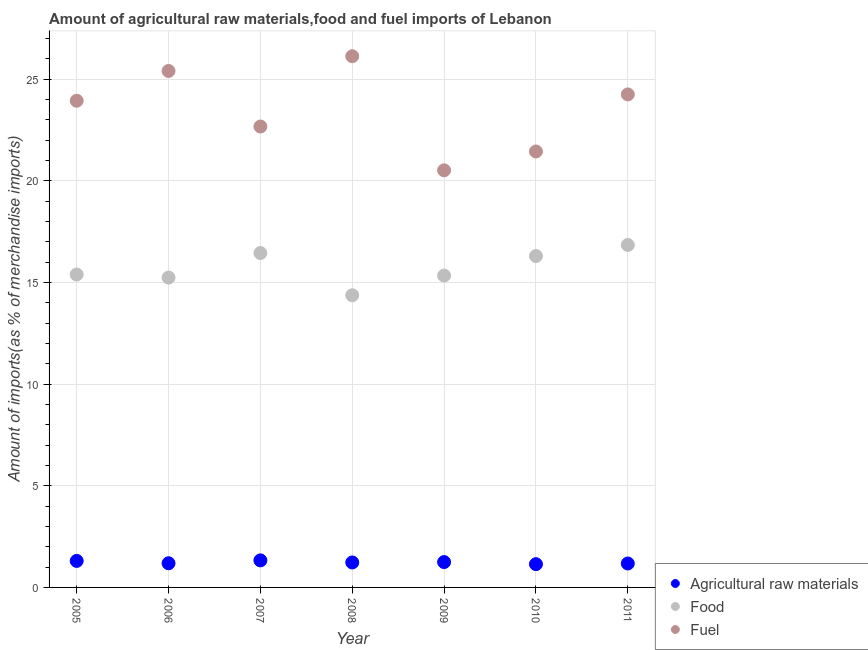What is the percentage of fuel imports in 2008?
Your answer should be compact. 26.12. Across all years, what is the maximum percentage of fuel imports?
Give a very brief answer. 26.12. Across all years, what is the minimum percentage of fuel imports?
Offer a very short reply. 20.51. In which year was the percentage of fuel imports maximum?
Provide a short and direct response. 2008. In which year was the percentage of fuel imports minimum?
Your answer should be very brief. 2009. What is the total percentage of raw materials imports in the graph?
Provide a succinct answer. 8.62. What is the difference between the percentage of food imports in 2009 and that in 2011?
Make the answer very short. -1.5. What is the difference between the percentage of food imports in 2010 and the percentage of fuel imports in 2005?
Offer a very short reply. -7.64. What is the average percentage of food imports per year?
Make the answer very short. 15.7. In the year 2006, what is the difference between the percentage of raw materials imports and percentage of food imports?
Your answer should be compact. -14.05. What is the ratio of the percentage of fuel imports in 2006 to that in 2010?
Provide a succinct answer. 1.18. Is the difference between the percentage of fuel imports in 2008 and 2009 greater than the difference between the percentage of food imports in 2008 and 2009?
Offer a terse response. Yes. What is the difference between the highest and the second highest percentage of fuel imports?
Give a very brief answer. 0.73. What is the difference between the highest and the lowest percentage of fuel imports?
Keep it short and to the point. 5.61. In how many years, is the percentage of raw materials imports greater than the average percentage of raw materials imports taken over all years?
Offer a terse response. 3. Is the sum of the percentage of food imports in 2009 and 2010 greater than the maximum percentage of raw materials imports across all years?
Your response must be concise. Yes. Is the percentage of fuel imports strictly greater than the percentage of food imports over the years?
Your answer should be very brief. Yes. Is the percentage of raw materials imports strictly less than the percentage of fuel imports over the years?
Your answer should be very brief. Yes. How many dotlines are there?
Make the answer very short. 3. How many years are there in the graph?
Offer a very short reply. 7. What is the difference between two consecutive major ticks on the Y-axis?
Offer a terse response. 5. Where does the legend appear in the graph?
Give a very brief answer. Bottom right. What is the title of the graph?
Your answer should be very brief. Amount of agricultural raw materials,food and fuel imports of Lebanon. What is the label or title of the X-axis?
Ensure brevity in your answer.  Year. What is the label or title of the Y-axis?
Your answer should be very brief. Amount of imports(as % of merchandise imports). What is the Amount of imports(as % of merchandise imports) of Agricultural raw materials in 2005?
Keep it short and to the point. 1.3. What is the Amount of imports(as % of merchandise imports) of Food in 2005?
Your answer should be very brief. 15.39. What is the Amount of imports(as % of merchandise imports) of Fuel in 2005?
Your answer should be compact. 23.93. What is the Amount of imports(as % of merchandise imports) of Agricultural raw materials in 2006?
Give a very brief answer. 1.19. What is the Amount of imports(as % of merchandise imports) in Food in 2006?
Ensure brevity in your answer.  15.24. What is the Amount of imports(as % of merchandise imports) of Fuel in 2006?
Offer a very short reply. 25.4. What is the Amount of imports(as % of merchandise imports) of Agricultural raw materials in 2007?
Your answer should be very brief. 1.33. What is the Amount of imports(as % of merchandise imports) in Food in 2007?
Provide a succinct answer. 16.44. What is the Amount of imports(as % of merchandise imports) of Fuel in 2007?
Your answer should be very brief. 22.67. What is the Amount of imports(as % of merchandise imports) of Agricultural raw materials in 2008?
Offer a very short reply. 1.23. What is the Amount of imports(as % of merchandise imports) of Food in 2008?
Your answer should be compact. 14.37. What is the Amount of imports(as % of merchandise imports) in Fuel in 2008?
Provide a succinct answer. 26.12. What is the Amount of imports(as % of merchandise imports) of Agricultural raw materials in 2009?
Keep it short and to the point. 1.25. What is the Amount of imports(as % of merchandise imports) in Food in 2009?
Your answer should be very brief. 15.34. What is the Amount of imports(as % of merchandise imports) of Fuel in 2009?
Your response must be concise. 20.51. What is the Amount of imports(as % of merchandise imports) of Agricultural raw materials in 2010?
Provide a succinct answer. 1.14. What is the Amount of imports(as % of merchandise imports) in Food in 2010?
Make the answer very short. 16.3. What is the Amount of imports(as % of merchandise imports) of Fuel in 2010?
Keep it short and to the point. 21.44. What is the Amount of imports(as % of merchandise imports) in Agricultural raw materials in 2011?
Offer a very short reply. 1.18. What is the Amount of imports(as % of merchandise imports) in Food in 2011?
Provide a short and direct response. 16.84. What is the Amount of imports(as % of merchandise imports) of Fuel in 2011?
Your response must be concise. 24.25. Across all years, what is the maximum Amount of imports(as % of merchandise imports) in Agricultural raw materials?
Provide a succinct answer. 1.33. Across all years, what is the maximum Amount of imports(as % of merchandise imports) of Food?
Give a very brief answer. 16.84. Across all years, what is the maximum Amount of imports(as % of merchandise imports) of Fuel?
Offer a very short reply. 26.12. Across all years, what is the minimum Amount of imports(as % of merchandise imports) in Agricultural raw materials?
Provide a succinct answer. 1.14. Across all years, what is the minimum Amount of imports(as % of merchandise imports) of Food?
Provide a succinct answer. 14.37. Across all years, what is the minimum Amount of imports(as % of merchandise imports) in Fuel?
Offer a very short reply. 20.51. What is the total Amount of imports(as % of merchandise imports) in Agricultural raw materials in the graph?
Your answer should be very brief. 8.62. What is the total Amount of imports(as % of merchandise imports) in Food in the graph?
Provide a short and direct response. 109.91. What is the total Amount of imports(as % of merchandise imports) of Fuel in the graph?
Make the answer very short. 164.32. What is the difference between the Amount of imports(as % of merchandise imports) of Agricultural raw materials in 2005 and that in 2006?
Ensure brevity in your answer.  0.11. What is the difference between the Amount of imports(as % of merchandise imports) in Food in 2005 and that in 2006?
Offer a very short reply. 0.15. What is the difference between the Amount of imports(as % of merchandise imports) of Fuel in 2005 and that in 2006?
Ensure brevity in your answer.  -1.46. What is the difference between the Amount of imports(as % of merchandise imports) of Agricultural raw materials in 2005 and that in 2007?
Your response must be concise. -0.03. What is the difference between the Amount of imports(as % of merchandise imports) in Food in 2005 and that in 2007?
Provide a succinct answer. -1.06. What is the difference between the Amount of imports(as % of merchandise imports) of Fuel in 2005 and that in 2007?
Keep it short and to the point. 1.27. What is the difference between the Amount of imports(as % of merchandise imports) in Agricultural raw materials in 2005 and that in 2008?
Offer a terse response. 0.08. What is the difference between the Amount of imports(as % of merchandise imports) in Food in 2005 and that in 2008?
Make the answer very short. 1.02. What is the difference between the Amount of imports(as % of merchandise imports) in Fuel in 2005 and that in 2008?
Give a very brief answer. -2.19. What is the difference between the Amount of imports(as % of merchandise imports) in Agricultural raw materials in 2005 and that in 2009?
Your answer should be compact. 0.06. What is the difference between the Amount of imports(as % of merchandise imports) in Food in 2005 and that in 2009?
Your answer should be very brief. 0.05. What is the difference between the Amount of imports(as % of merchandise imports) in Fuel in 2005 and that in 2009?
Your response must be concise. 3.42. What is the difference between the Amount of imports(as % of merchandise imports) of Agricultural raw materials in 2005 and that in 2010?
Your response must be concise. 0.16. What is the difference between the Amount of imports(as % of merchandise imports) in Food in 2005 and that in 2010?
Make the answer very short. -0.91. What is the difference between the Amount of imports(as % of merchandise imports) in Fuel in 2005 and that in 2010?
Your answer should be very brief. 2.49. What is the difference between the Amount of imports(as % of merchandise imports) in Agricultural raw materials in 2005 and that in 2011?
Give a very brief answer. 0.13. What is the difference between the Amount of imports(as % of merchandise imports) of Food in 2005 and that in 2011?
Your answer should be very brief. -1.45. What is the difference between the Amount of imports(as % of merchandise imports) in Fuel in 2005 and that in 2011?
Offer a terse response. -0.31. What is the difference between the Amount of imports(as % of merchandise imports) in Agricultural raw materials in 2006 and that in 2007?
Offer a very short reply. -0.14. What is the difference between the Amount of imports(as % of merchandise imports) of Food in 2006 and that in 2007?
Give a very brief answer. -1.21. What is the difference between the Amount of imports(as % of merchandise imports) of Fuel in 2006 and that in 2007?
Ensure brevity in your answer.  2.73. What is the difference between the Amount of imports(as % of merchandise imports) in Agricultural raw materials in 2006 and that in 2008?
Your answer should be very brief. -0.04. What is the difference between the Amount of imports(as % of merchandise imports) in Food in 2006 and that in 2008?
Provide a succinct answer. 0.87. What is the difference between the Amount of imports(as % of merchandise imports) in Fuel in 2006 and that in 2008?
Ensure brevity in your answer.  -0.73. What is the difference between the Amount of imports(as % of merchandise imports) of Agricultural raw materials in 2006 and that in 2009?
Provide a succinct answer. -0.06. What is the difference between the Amount of imports(as % of merchandise imports) of Food in 2006 and that in 2009?
Your answer should be very brief. -0.1. What is the difference between the Amount of imports(as % of merchandise imports) of Fuel in 2006 and that in 2009?
Provide a succinct answer. 4.89. What is the difference between the Amount of imports(as % of merchandise imports) of Agricultural raw materials in 2006 and that in 2010?
Provide a short and direct response. 0.04. What is the difference between the Amount of imports(as % of merchandise imports) of Food in 2006 and that in 2010?
Give a very brief answer. -1.06. What is the difference between the Amount of imports(as % of merchandise imports) of Fuel in 2006 and that in 2010?
Your response must be concise. 3.96. What is the difference between the Amount of imports(as % of merchandise imports) in Agricultural raw materials in 2006 and that in 2011?
Give a very brief answer. 0.01. What is the difference between the Amount of imports(as % of merchandise imports) in Food in 2006 and that in 2011?
Give a very brief answer. -1.6. What is the difference between the Amount of imports(as % of merchandise imports) of Fuel in 2006 and that in 2011?
Offer a terse response. 1.15. What is the difference between the Amount of imports(as % of merchandise imports) of Agricultural raw materials in 2007 and that in 2008?
Make the answer very short. 0.1. What is the difference between the Amount of imports(as % of merchandise imports) in Food in 2007 and that in 2008?
Give a very brief answer. 2.08. What is the difference between the Amount of imports(as % of merchandise imports) in Fuel in 2007 and that in 2008?
Your answer should be compact. -3.46. What is the difference between the Amount of imports(as % of merchandise imports) in Agricultural raw materials in 2007 and that in 2009?
Your answer should be compact. 0.08. What is the difference between the Amount of imports(as % of merchandise imports) in Food in 2007 and that in 2009?
Provide a succinct answer. 1.11. What is the difference between the Amount of imports(as % of merchandise imports) of Fuel in 2007 and that in 2009?
Keep it short and to the point. 2.15. What is the difference between the Amount of imports(as % of merchandise imports) of Agricultural raw materials in 2007 and that in 2010?
Your response must be concise. 0.19. What is the difference between the Amount of imports(as % of merchandise imports) of Food in 2007 and that in 2010?
Provide a succinct answer. 0.15. What is the difference between the Amount of imports(as % of merchandise imports) in Fuel in 2007 and that in 2010?
Your response must be concise. 1.23. What is the difference between the Amount of imports(as % of merchandise imports) in Agricultural raw materials in 2007 and that in 2011?
Make the answer very short. 0.15. What is the difference between the Amount of imports(as % of merchandise imports) in Food in 2007 and that in 2011?
Make the answer very short. -0.4. What is the difference between the Amount of imports(as % of merchandise imports) of Fuel in 2007 and that in 2011?
Give a very brief answer. -1.58. What is the difference between the Amount of imports(as % of merchandise imports) in Agricultural raw materials in 2008 and that in 2009?
Your answer should be compact. -0.02. What is the difference between the Amount of imports(as % of merchandise imports) in Food in 2008 and that in 2009?
Your answer should be compact. -0.97. What is the difference between the Amount of imports(as % of merchandise imports) in Fuel in 2008 and that in 2009?
Offer a terse response. 5.61. What is the difference between the Amount of imports(as % of merchandise imports) of Agricultural raw materials in 2008 and that in 2010?
Keep it short and to the point. 0.08. What is the difference between the Amount of imports(as % of merchandise imports) in Food in 2008 and that in 2010?
Give a very brief answer. -1.93. What is the difference between the Amount of imports(as % of merchandise imports) in Fuel in 2008 and that in 2010?
Provide a short and direct response. 4.68. What is the difference between the Amount of imports(as % of merchandise imports) in Agricultural raw materials in 2008 and that in 2011?
Keep it short and to the point. 0.05. What is the difference between the Amount of imports(as % of merchandise imports) in Food in 2008 and that in 2011?
Keep it short and to the point. -2.47. What is the difference between the Amount of imports(as % of merchandise imports) in Fuel in 2008 and that in 2011?
Give a very brief answer. 1.88. What is the difference between the Amount of imports(as % of merchandise imports) of Agricultural raw materials in 2009 and that in 2010?
Offer a terse response. 0.1. What is the difference between the Amount of imports(as % of merchandise imports) of Food in 2009 and that in 2010?
Give a very brief answer. -0.96. What is the difference between the Amount of imports(as % of merchandise imports) in Fuel in 2009 and that in 2010?
Your answer should be compact. -0.93. What is the difference between the Amount of imports(as % of merchandise imports) of Agricultural raw materials in 2009 and that in 2011?
Your response must be concise. 0.07. What is the difference between the Amount of imports(as % of merchandise imports) of Food in 2009 and that in 2011?
Give a very brief answer. -1.5. What is the difference between the Amount of imports(as % of merchandise imports) in Fuel in 2009 and that in 2011?
Your answer should be compact. -3.73. What is the difference between the Amount of imports(as % of merchandise imports) in Agricultural raw materials in 2010 and that in 2011?
Provide a short and direct response. -0.03. What is the difference between the Amount of imports(as % of merchandise imports) of Food in 2010 and that in 2011?
Offer a terse response. -0.54. What is the difference between the Amount of imports(as % of merchandise imports) in Fuel in 2010 and that in 2011?
Your response must be concise. -2.81. What is the difference between the Amount of imports(as % of merchandise imports) of Agricultural raw materials in 2005 and the Amount of imports(as % of merchandise imports) of Food in 2006?
Provide a succinct answer. -13.93. What is the difference between the Amount of imports(as % of merchandise imports) of Agricultural raw materials in 2005 and the Amount of imports(as % of merchandise imports) of Fuel in 2006?
Keep it short and to the point. -24.09. What is the difference between the Amount of imports(as % of merchandise imports) in Food in 2005 and the Amount of imports(as % of merchandise imports) in Fuel in 2006?
Your response must be concise. -10.01. What is the difference between the Amount of imports(as % of merchandise imports) in Agricultural raw materials in 2005 and the Amount of imports(as % of merchandise imports) in Food in 2007?
Make the answer very short. -15.14. What is the difference between the Amount of imports(as % of merchandise imports) of Agricultural raw materials in 2005 and the Amount of imports(as % of merchandise imports) of Fuel in 2007?
Your answer should be very brief. -21.36. What is the difference between the Amount of imports(as % of merchandise imports) in Food in 2005 and the Amount of imports(as % of merchandise imports) in Fuel in 2007?
Ensure brevity in your answer.  -7.28. What is the difference between the Amount of imports(as % of merchandise imports) of Agricultural raw materials in 2005 and the Amount of imports(as % of merchandise imports) of Food in 2008?
Offer a terse response. -13.06. What is the difference between the Amount of imports(as % of merchandise imports) of Agricultural raw materials in 2005 and the Amount of imports(as % of merchandise imports) of Fuel in 2008?
Your response must be concise. -24.82. What is the difference between the Amount of imports(as % of merchandise imports) in Food in 2005 and the Amount of imports(as % of merchandise imports) in Fuel in 2008?
Provide a short and direct response. -10.74. What is the difference between the Amount of imports(as % of merchandise imports) in Agricultural raw materials in 2005 and the Amount of imports(as % of merchandise imports) in Food in 2009?
Provide a short and direct response. -14.03. What is the difference between the Amount of imports(as % of merchandise imports) of Agricultural raw materials in 2005 and the Amount of imports(as % of merchandise imports) of Fuel in 2009?
Your answer should be compact. -19.21. What is the difference between the Amount of imports(as % of merchandise imports) in Food in 2005 and the Amount of imports(as % of merchandise imports) in Fuel in 2009?
Make the answer very short. -5.12. What is the difference between the Amount of imports(as % of merchandise imports) in Agricultural raw materials in 2005 and the Amount of imports(as % of merchandise imports) in Food in 2010?
Ensure brevity in your answer.  -14.99. What is the difference between the Amount of imports(as % of merchandise imports) in Agricultural raw materials in 2005 and the Amount of imports(as % of merchandise imports) in Fuel in 2010?
Provide a succinct answer. -20.14. What is the difference between the Amount of imports(as % of merchandise imports) in Food in 2005 and the Amount of imports(as % of merchandise imports) in Fuel in 2010?
Your response must be concise. -6.05. What is the difference between the Amount of imports(as % of merchandise imports) in Agricultural raw materials in 2005 and the Amount of imports(as % of merchandise imports) in Food in 2011?
Offer a terse response. -15.54. What is the difference between the Amount of imports(as % of merchandise imports) of Agricultural raw materials in 2005 and the Amount of imports(as % of merchandise imports) of Fuel in 2011?
Provide a succinct answer. -22.94. What is the difference between the Amount of imports(as % of merchandise imports) of Food in 2005 and the Amount of imports(as % of merchandise imports) of Fuel in 2011?
Provide a succinct answer. -8.86. What is the difference between the Amount of imports(as % of merchandise imports) of Agricultural raw materials in 2006 and the Amount of imports(as % of merchandise imports) of Food in 2007?
Your answer should be compact. -15.26. What is the difference between the Amount of imports(as % of merchandise imports) in Agricultural raw materials in 2006 and the Amount of imports(as % of merchandise imports) in Fuel in 2007?
Make the answer very short. -21.48. What is the difference between the Amount of imports(as % of merchandise imports) of Food in 2006 and the Amount of imports(as % of merchandise imports) of Fuel in 2007?
Provide a succinct answer. -7.43. What is the difference between the Amount of imports(as % of merchandise imports) in Agricultural raw materials in 2006 and the Amount of imports(as % of merchandise imports) in Food in 2008?
Give a very brief answer. -13.18. What is the difference between the Amount of imports(as % of merchandise imports) in Agricultural raw materials in 2006 and the Amount of imports(as % of merchandise imports) in Fuel in 2008?
Offer a very short reply. -24.93. What is the difference between the Amount of imports(as % of merchandise imports) of Food in 2006 and the Amount of imports(as % of merchandise imports) of Fuel in 2008?
Offer a very short reply. -10.89. What is the difference between the Amount of imports(as % of merchandise imports) in Agricultural raw materials in 2006 and the Amount of imports(as % of merchandise imports) in Food in 2009?
Provide a succinct answer. -14.15. What is the difference between the Amount of imports(as % of merchandise imports) in Agricultural raw materials in 2006 and the Amount of imports(as % of merchandise imports) in Fuel in 2009?
Provide a short and direct response. -19.32. What is the difference between the Amount of imports(as % of merchandise imports) of Food in 2006 and the Amount of imports(as % of merchandise imports) of Fuel in 2009?
Your response must be concise. -5.28. What is the difference between the Amount of imports(as % of merchandise imports) of Agricultural raw materials in 2006 and the Amount of imports(as % of merchandise imports) of Food in 2010?
Give a very brief answer. -15.11. What is the difference between the Amount of imports(as % of merchandise imports) in Agricultural raw materials in 2006 and the Amount of imports(as % of merchandise imports) in Fuel in 2010?
Your answer should be very brief. -20.25. What is the difference between the Amount of imports(as % of merchandise imports) of Food in 2006 and the Amount of imports(as % of merchandise imports) of Fuel in 2010?
Keep it short and to the point. -6.2. What is the difference between the Amount of imports(as % of merchandise imports) of Agricultural raw materials in 2006 and the Amount of imports(as % of merchandise imports) of Food in 2011?
Make the answer very short. -15.65. What is the difference between the Amount of imports(as % of merchandise imports) in Agricultural raw materials in 2006 and the Amount of imports(as % of merchandise imports) in Fuel in 2011?
Offer a very short reply. -23.06. What is the difference between the Amount of imports(as % of merchandise imports) in Food in 2006 and the Amount of imports(as % of merchandise imports) in Fuel in 2011?
Provide a succinct answer. -9.01. What is the difference between the Amount of imports(as % of merchandise imports) of Agricultural raw materials in 2007 and the Amount of imports(as % of merchandise imports) of Food in 2008?
Your answer should be very brief. -13.04. What is the difference between the Amount of imports(as % of merchandise imports) of Agricultural raw materials in 2007 and the Amount of imports(as % of merchandise imports) of Fuel in 2008?
Your response must be concise. -24.79. What is the difference between the Amount of imports(as % of merchandise imports) of Food in 2007 and the Amount of imports(as % of merchandise imports) of Fuel in 2008?
Provide a succinct answer. -9.68. What is the difference between the Amount of imports(as % of merchandise imports) of Agricultural raw materials in 2007 and the Amount of imports(as % of merchandise imports) of Food in 2009?
Your answer should be very brief. -14.01. What is the difference between the Amount of imports(as % of merchandise imports) in Agricultural raw materials in 2007 and the Amount of imports(as % of merchandise imports) in Fuel in 2009?
Provide a short and direct response. -19.18. What is the difference between the Amount of imports(as % of merchandise imports) of Food in 2007 and the Amount of imports(as % of merchandise imports) of Fuel in 2009?
Offer a very short reply. -4.07. What is the difference between the Amount of imports(as % of merchandise imports) of Agricultural raw materials in 2007 and the Amount of imports(as % of merchandise imports) of Food in 2010?
Your answer should be compact. -14.97. What is the difference between the Amount of imports(as % of merchandise imports) in Agricultural raw materials in 2007 and the Amount of imports(as % of merchandise imports) in Fuel in 2010?
Your answer should be compact. -20.11. What is the difference between the Amount of imports(as % of merchandise imports) of Food in 2007 and the Amount of imports(as % of merchandise imports) of Fuel in 2010?
Offer a terse response. -5. What is the difference between the Amount of imports(as % of merchandise imports) of Agricultural raw materials in 2007 and the Amount of imports(as % of merchandise imports) of Food in 2011?
Your response must be concise. -15.51. What is the difference between the Amount of imports(as % of merchandise imports) in Agricultural raw materials in 2007 and the Amount of imports(as % of merchandise imports) in Fuel in 2011?
Your answer should be very brief. -22.92. What is the difference between the Amount of imports(as % of merchandise imports) of Food in 2007 and the Amount of imports(as % of merchandise imports) of Fuel in 2011?
Give a very brief answer. -7.8. What is the difference between the Amount of imports(as % of merchandise imports) of Agricultural raw materials in 2008 and the Amount of imports(as % of merchandise imports) of Food in 2009?
Provide a succinct answer. -14.11. What is the difference between the Amount of imports(as % of merchandise imports) in Agricultural raw materials in 2008 and the Amount of imports(as % of merchandise imports) in Fuel in 2009?
Your answer should be very brief. -19.28. What is the difference between the Amount of imports(as % of merchandise imports) of Food in 2008 and the Amount of imports(as % of merchandise imports) of Fuel in 2009?
Your answer should be very brief. -6.14. What is the difference between the Amount of imports(as % of merchandise imports) of Agricultural raw materials in 2008 and the Amount of imports(as % of merchandise imports) of Food in 2010?
Your answer should be compact. -15.07. What is the difference between the Amount of imports(as % of merchandise imports) in Agricultural raw materials in 2008 and the Amount of imports(as % of merchandise imports) in Fuel in 2010?
Provide a short and direct response. -20.21. What is the difference between the Amount of imports(as % of merchandise imports) of Food in 2008 and the Amount of imports(as % of merchandise imports) of Fuel in 2010?
Ensure brevity in your answer.  -7.07. What is the difference between the Amount of imports(as % of merchandise imports) of Agricultural raw materials in 2008 and the Amount of imports(as % of merchandise imports) of Food in 2011?
Provide a succinct answer. -15.61. What is the difference between the Amount of imports(as % of merchandise imports) of Agricultural raw materials in 2008 and the Amount of imports(as % of merchandise imports) of Fuel in 2011?
Your response must be concise. -23.02. What is the difference between the Amount of imports(as % of merchandise imports) of Food in 2008 and the Amount of imports(as % of merchandise imports) of Fuel in 2011?
Your response must be concise. -9.88. What is the difference between the Amount of imports(as % of merchandise imports) of Agricultural raw materials in 2009 and the Amount of imports(as % of merchandise imports) of Food in 2010?
Give a very brief answer. -15.05. What is the difference between the Amount of imports(as % of merchandise imports) of Agricultural raw materials in 2009 and the Amount of imports(as % of merchandise imports) of Fuel in 2010?
Offer a terse response. -20.19. What is the difference between the Amount of imports(as % of merchandise imports) in Food in 2009 and the Amount of imports(as % of merchandise imports) in Fuel in 2010?
Your answer should be very brief. -6.1. What is the difference between the Amount of imports(as % of merchandise imports) in Agricultural raw materials in 2009 and the Amount of imports(as % of merchandise imports) in Food in 2011?
Your response must be concise. -15.59. What is the difference between the Amount of imports(as % of merchandise imports) of Agricultural raw materials in 2009 and the Amount of imports(as % of merchandise imports) of Fuel in 2011?
Ensure brevity in your answer.  -23. What is the difference between the Amount of imports(as % of merchandise imports) of Food in 2009 and the Amount of imports(as % of merchandise imports) of Fuel in 2011?
Offer a terse response. -8.91. What is the difference between the Amount of imports(as % of merchandise imports) in Agricultural raw materials in 2010 and the Amount of imports(as % of merchandise imports) in Food in 2011?
Offer a very short reply. -15.7. What is the difference between the Amount of imports(as % of merchandise imports) in Agricultural raw materials in 2010 and the Amount of imports(as % of merchandise imports) in Fuel in 2011?
Offer a terse response. -23.1. What is the difference between the Amount of imports(as % of merchandise imports) in Food in 2010 and the Amount of imports(as % of merchandise imports) in Fuel in 2011?
Your response must be concise. -7.95. What is the average Amount of imports(as % of merchandise imports) of Agricultural raw materials per year?
Offer a terse response. 1.23. What is the average Amount of imports(as % of merchandise imports) in Food per year?
Provide a succinct answer. 15.7. What is the average Amount of imports(as % of merchandise imports) in Fuel per year?
Provide a short and direct response. 23.47. In the year 2005, what is the difference between the Amount of imports(as % of merchandise imports) of Agricultural raw materials and Amount of imports(as % of merchandise imports) of Food?
Keep it short and to the point. -14.08. In the year 2005, what is the difference between the Amount of imports(as % of merchandise imports) in Agricultural raw materials and Amount of imports(as % of merchandise imports) in Fuel?
Offer a terse response. -22.63. In the year 2005, what is the difference between the Amount of imports(as % of merchandise imports) in Food and Amount of imports(as % of merchandise imports) in Fuel?
Make the answer very short. -8.55. In the year 2006, what is the difference between the Amount of imports(as % of merchandise imports) of Agricultural raw materials and Amount of imports(as % of merchandise imports) of Food?
Give a very brief answer. -14.05. In the year 2006, what is the difference between the Amount of imports(as % of merchandise imports) in Agricultural raw materials and Amount of imports(as % of merchandise imports) in Fuel?
Provide a short and direct response. -24.21. In the year 2006, what is the difference between the Amount of imports(as % of merchandise imports) in Food and Amount of imports(as % of merchandise imports) in Fuel?
Your answer should be compact. -10.16. In the year 2007, what is the difference between the Amount of imports(as % of merchandise imports) of Agricultural raw materials and Amount of imports(as % of merchandise imports) of Food?
Give a very brief answer. -15.11. In the year 2007, what is the difference between the Amount of imports(as % of merchandise imports) of Agricultural raw materials and Amount of imports(as % of merchandise imports) of Fuel?
Offer a terse response. -21.34. In the year 2007, what is the difference between the Amount of imports(as % of merchandise imports) of Food and Amount of imports(as % of merchandise imports) of Fuel?
Your response must be concise. -6.22. In the year 2008, what is the difference between the Amount of imports(as % of merchandise imports) of Agricultural raw materials and Amount of imports(as % of merchandise imports) of Food?
Provide a short and direct response. -13.14. In the year 2008, what is the difference between the Amount of imports(as % of merchandise imports) of Agricultural raw materials and Amount of imports(as % of merchandise imports) of Fuel?
Your answer should be very brief. -24.9. In the year 2008, what is the difference between the Amount of imports(as % of merchandise imports) in Food and Amount of imports(as % of merchandise imports) in Fuel?
Provide a succinct answer. -11.76. In the year 2009, what is the difference between the Amount of imports(as % of merchandise imports) in Agricultural raw materials and Amount of imports(as % of merchandise imports) in Food?
Provide a succinct answer. -14.09. In the year 2009, what is the difference between the Amount of imports(as % of merchandise imports) of Agricultural raw materials and Amount of imports(as % of merchandise imports) of Fuel?
Provide a short and direct response. -19.27. In the year 2009, what is the difference between the Amount of imports(as % of merchandise imports) of Food and Amount of imports(as % of merchandise imports) of Fuel?
Make the answer very short. -5.18. In the year 2010, what is the difference between the Amount of imports(as % of merchandise imports) of Agricultural raw materials and Amount of imports(as % of merchandise imports) of Food?
Make the answer very short. -15.15. In the year 2010, what is the difference between the Amount of imports(as % of merchandise imports) in Agricultural raw materials and Amount of imports(as % of merchandise imports) in Fuel?
Ensure brevity in your answer.  -20.3. In the year 2010, what is the difference between the Amount of imports(as % of merchandise imports) of Food and Amount of imports(as % of merchandise imports) of Fuel?
Provide a succinct answer. -5.14. In the year 2011, what is the difference between the Amount of imports(as % of merchandise imports) in Agricultural raw materials and Amount of imports(as % of merchandise imports) in Food?
Provide a short and direct response. -15.66. In the year 2011, what is the difference between the Amount of imports(as % of merchandise imports) of Agricultural raw materials and Amount of imports(as % of merchandise imports) of Fuel?
Offer a very short reply. -23.07. In the year 2011, what is the difference between the Amount of imports(as % of merchandise imports) in Food and Amount of imports(as % of merchandise imports) in Fuel?
Your answer should be compact. -7.41. What is the ratio of the Amount of imports(as % of merchandise imports) of Agricultural raw materials in 2005 to that in 2006?
Your answer should be very brief. 1.1. What is the ratio of the Amount of imports(as % of merchandise imports) of Food in 2005 to that in 2006?
Make the answer very short. 1.01. What is the ratio of the Amount of imports(as % of merchandise imports) in Fuel in 2005 to that in 2006?
Make the answer very short. 0.94. What is the ratio of the Amount of imports(as % of merchandise imports) in Agricultural raw materials in 2005 to that in 2007?
Your answer should be compact. 0.98. What is the ratio of the Amount of imports(as % of merchandise imports) of Food in 2005 to that in 2007?
Keep it short and to the point. 0.94. What is the ratio of the Amount of imports(as % of merchandise imports) in Fuel in 2005 to that in 2007?
Offer a terse response. 1.06. What is the ratio of the Amount of imports(as % of merchandise imports) of Agricultural raw materials in 2005 to that in 2008?
Provide a succinct answer. 1.06. What is the ratio of the Amount of imports(as % of merchandise imports) of Food in 2005 to that in 2008?
Offer a terse response. 1.07. What is the ratio of the Amount of imports(as % of merchandise imports) of Fuel in 2005 to that in 2008?
Your answer should be compact. 0.92. What is the ratio of the Amount of imports(as % of merchandise imports) of Agricultural raw materials in 2005 to that in 2009?
Your answer should be very brief. 1.05. What is the ratio of the Amount of imports(as % of merchandise imports) in Food in 2005 to that in 2009?
Provide a short and direct response. 1. What is the ratio of the Amount of imports(as % of merchandise imports) in Fuel in 2005 to that in 2009?
Ensure brevity in your answer.  1.17. What is the ratio of the Amount of imports(as % of merchandise imports) of Agricultural raw materials in 2005 to that in 2010?
Provide a succinct answer. 1.14. What is the ratio of the Amount of imports(as % of merchandise imports) of Food in 2005 to that in 2010?
Offer a very short reply. 0.94. What is the ratio of the Amount of imports(as % of merchandise imports) of Fuel in 2005 to that in 2010?
Keep it short and to the point. 1.12. What is the ratio of the Amount of imports(as % of merchandise imports) of Agricultural raw materials in 2005 to that in 2011?
Your answer should be compact. 1.11. What is the ratio of the Amount of imports(as % of merchandise imports) of Food in 2005 to that in 2011?
Provide a succinct answer. 0.91. What is the ratio of the Amount of imports(as % of merchandise imports) of Fuel in 2005 to that in 2011?
Provide a succinct answer. 0.99. What is the ratio of the Amount of imports(as % of merchandise imports) in Agricultural raw materials in 2006 to that in 2007?
Provide a short and direct response. 0.89. What is the ratio of the Amount of imports(as % of merchandise imports) of Food in 2006 to that in 2007?
Ensure brevity in your answer.  0.93. What is the ratio of the Amount of imports(as % of merchandise imports) of Fuel in 2006 to that in 2007?
Offer a very short reply. 1.12. What is the ratio of the Amount of imports(as % of merchandise imports) in Agricultural raw materials in 2006 to that in 2008?
Offer a very short reply. 0.97. What is the ratio of the Amount of imports(as % of merchandise imports) in Food in 2006 to that in 2008?
Provide a short and direct response. 1.06. What is the ratio of the Amount of imports(as % of merchandise imports) of Fuel in 2006 to that in 2008?
Your response must be concise. 0.97. What is the ratio of the Amount of imports(as % of merchandise imports) of Agricultural raw materials in 2006 to that in 2009?
Provide a succinct answer. 0.95. What is the ratio of the Amount of imports(as % of merchandise imports) in Food in 2006 to that in 2009?
Offer a terse response. 0.99. What is the ratio of the Amount of imports(as % of merchandise imports) in Fuel in 2006 to that in 2009?
Offer a very short reply. 1.24. What is the ratio of the Amount of imports(as % of merchandise imports) in Agricultural raw materials in 2006 to that in 2010?
Keep it short and to the point. 1.04. What is the ratio of the Amount of imports(as % of merchandise imports) in Food in 2006 to that in 2010?
Offer a very short reply. 0.93. What is the ratio of the Amount of imports(as % of merchandise imports) in Fuel in 2006 to that in 2010?
Give a very brief answer. 1.18. What is the ratio of the Amount of imports(as % of merchandise imports) of Agricultural raw materials in 2006 to that in 2011?
Your answer should be compact. 1.01. What is the ratio of the Amount of imports(as % of merchandise imports) in Food in 2006 to that in 2011?
Offer a terse response. 0.9. What is the ratio of the Amount of imports(as % of merchandise imports) of Fuel in 2006 to that in 2011?
Ensure brevity in your answer.  1.05. What is the ratio of the Amount of imports(as % of merchandise imports) of Food in 2007 to that in 2008?
Provide a short and direct response. 1.14. What is the ratio of the Amount of imports(as % of merchandise imports) in Fuel in 2007 to that in 2008?
Make the answer very short. 0.87. What is the ratio of the Amount of imports(as % of merchandise imports) of Agricultural raw materials in 2007 to that in 2009?
Provide a succinct answer. 1.07. What is the ratio of the Amount of imports(as % of merchandise imports) of Food in 2007 to that in 2009?
Provide a succinct answer. 1.07. What is the ratio of the Amount of imports(as % of merchandise imports) of Fuel in 2007 to that in 2009?
Provide a short and direct response. 1.1. What is the ratio of the Amount of imports(as % of merchandise imports) of Agricultural raw materials in 2007 to that in 2010?
Provide a short and direct response. 1.16. What is the ratio of the Amount of imports(as % of merchandise imports) in Fuel in 2007 to that in 2010?
Keep it short and to the point. 1.06. What is the ratio of the Amount of imports(as % of merchandise imports) in Agricultural raw materials in 2007 to that in 2011?
Your answer should be compact. 1.13. What is the ratio of the Amount of imports(as % of merchandise imports) in Food in 2007 to that in 2011?
Ensure brevity in your answer.  0.98. What is the ratio of the Amount of imports(as % of merchandise imports) of Fuel in 2007 to that in 2011?
Offer a terse response. 0.93. What is the ratio of the Amount of imports(as % of merchandise imports) in Agricultural raw materials in 2008 to that in 2009?
Provide a succinct answer. 0.99. What is the ratio of the Amount of imports(as % of merchandise imports) in Food in 2008 to that in 2009?
Offer a very short reply. 0.94. What is the ratio of the Amount of imports(as % of merchandise imports) of Fuel in 2008 to that in 2009?
Ensure brevity in your answer.  1.27. What is the ratio of the Amount of imports(as % of merchandise imports) in Agricultural raw materials in 2008 to that in 2010?
Provide a succinct answer. 1.07. What is the ratio of the Amount of imports(as % of merchandise imports) in Food in 2008 to that in 2010?
Offer a terse response. 0.88. What is the ratio of the Amount of imports(as % of merchandise imports) of Fuel in 2008 to that in 2010?
Offer a terse response. 1.22. What is the ratio of the Amount of imports(as % of merchandise imports) of Agricultural raw materials in 2008 to that in 2011?
Give a very brief answer. 1.04. What is the ratio of the Amount of imports(as % of merchandise imports) in Food in 2008 to that in 2011?
Give a very brief answer. 0.85. What is the ratio of the Amount of imports(as % of merchandise imports) of Fuel in 2008 to that in 2011?
Your answer should be very brief. 1.08. What is the ratio of the Amount of imports(as % of merchandise imports) in Agricultural raw materials in 2009 to that in 2010?
Give a very brief answer. 1.09. What is the ratio of the Amount of imports(as % of merchandise imports) in Food in 2009 to that in 2010?
Your response must be concise. 0.94. What is the ratio of the Amount of imports(as % of merchandise imports) in Fuel in 2009 to that in 2010?
Offer a very short reply. 0.96. What is the ratio of the Amount of imports(as % of merchandise imports) of Agricultural raw materials in 2009 to that in 2011?
Keep it short and to the point. 1.06. What is the ratio of the Amount of imports(as % of merchandise imports) in Food in 2009 to that in 2011?
Offer a very short reply. 0.91. What is the ratio of the Amount of imports(as % of merchandise imports) in Fuel in 2009 to that in 2011?
Provide a short and direct response. 0.85. What is the ratio of the Amount of imports(as % of merchandise imports) in Agricultural raw materials in 2010 to that in 2011?
Your response must be concise. 0.97. What is the ratio of the Amount of imports(as % of merchandise imports) of Food in 2010 to that in 2011?
Make the answer very short. 0.97. What is the ratio of the Amount of imports(as % of merchandise imports) of Fuel in 2010 to that in 2011?
Offer a terse response. 0.88. What is the difference between the highest and the second highest Amount of imports(as % of merchandise imports) of Agricultural raw materials?
Your answer should be very brief. 0.03. What is the difference between the highest and the second highest Amount of imports(as % of merchandise imports) of Food?
Offer a very short reply. 0.4. What is the difference between the highest and the second highest Amount of imports(as % of merchandise imports) of Fuel?
Keep it short and to the point. 0.73. What is the difference between the highest and the lowest Amount of imports(as % of merchandise imports) of Agricultural raw materials?
Offer a very short reply. 0.19. What is the difference between the highest and the lowest Amount of imports(as % of merchandise imports) in Food?
Keep it short and to the point. 2.47. What is the difference between the highest and the lowest Amount of imports(as % of merchandise imports) of Fuel?
Make the answer very short. 5.61. 